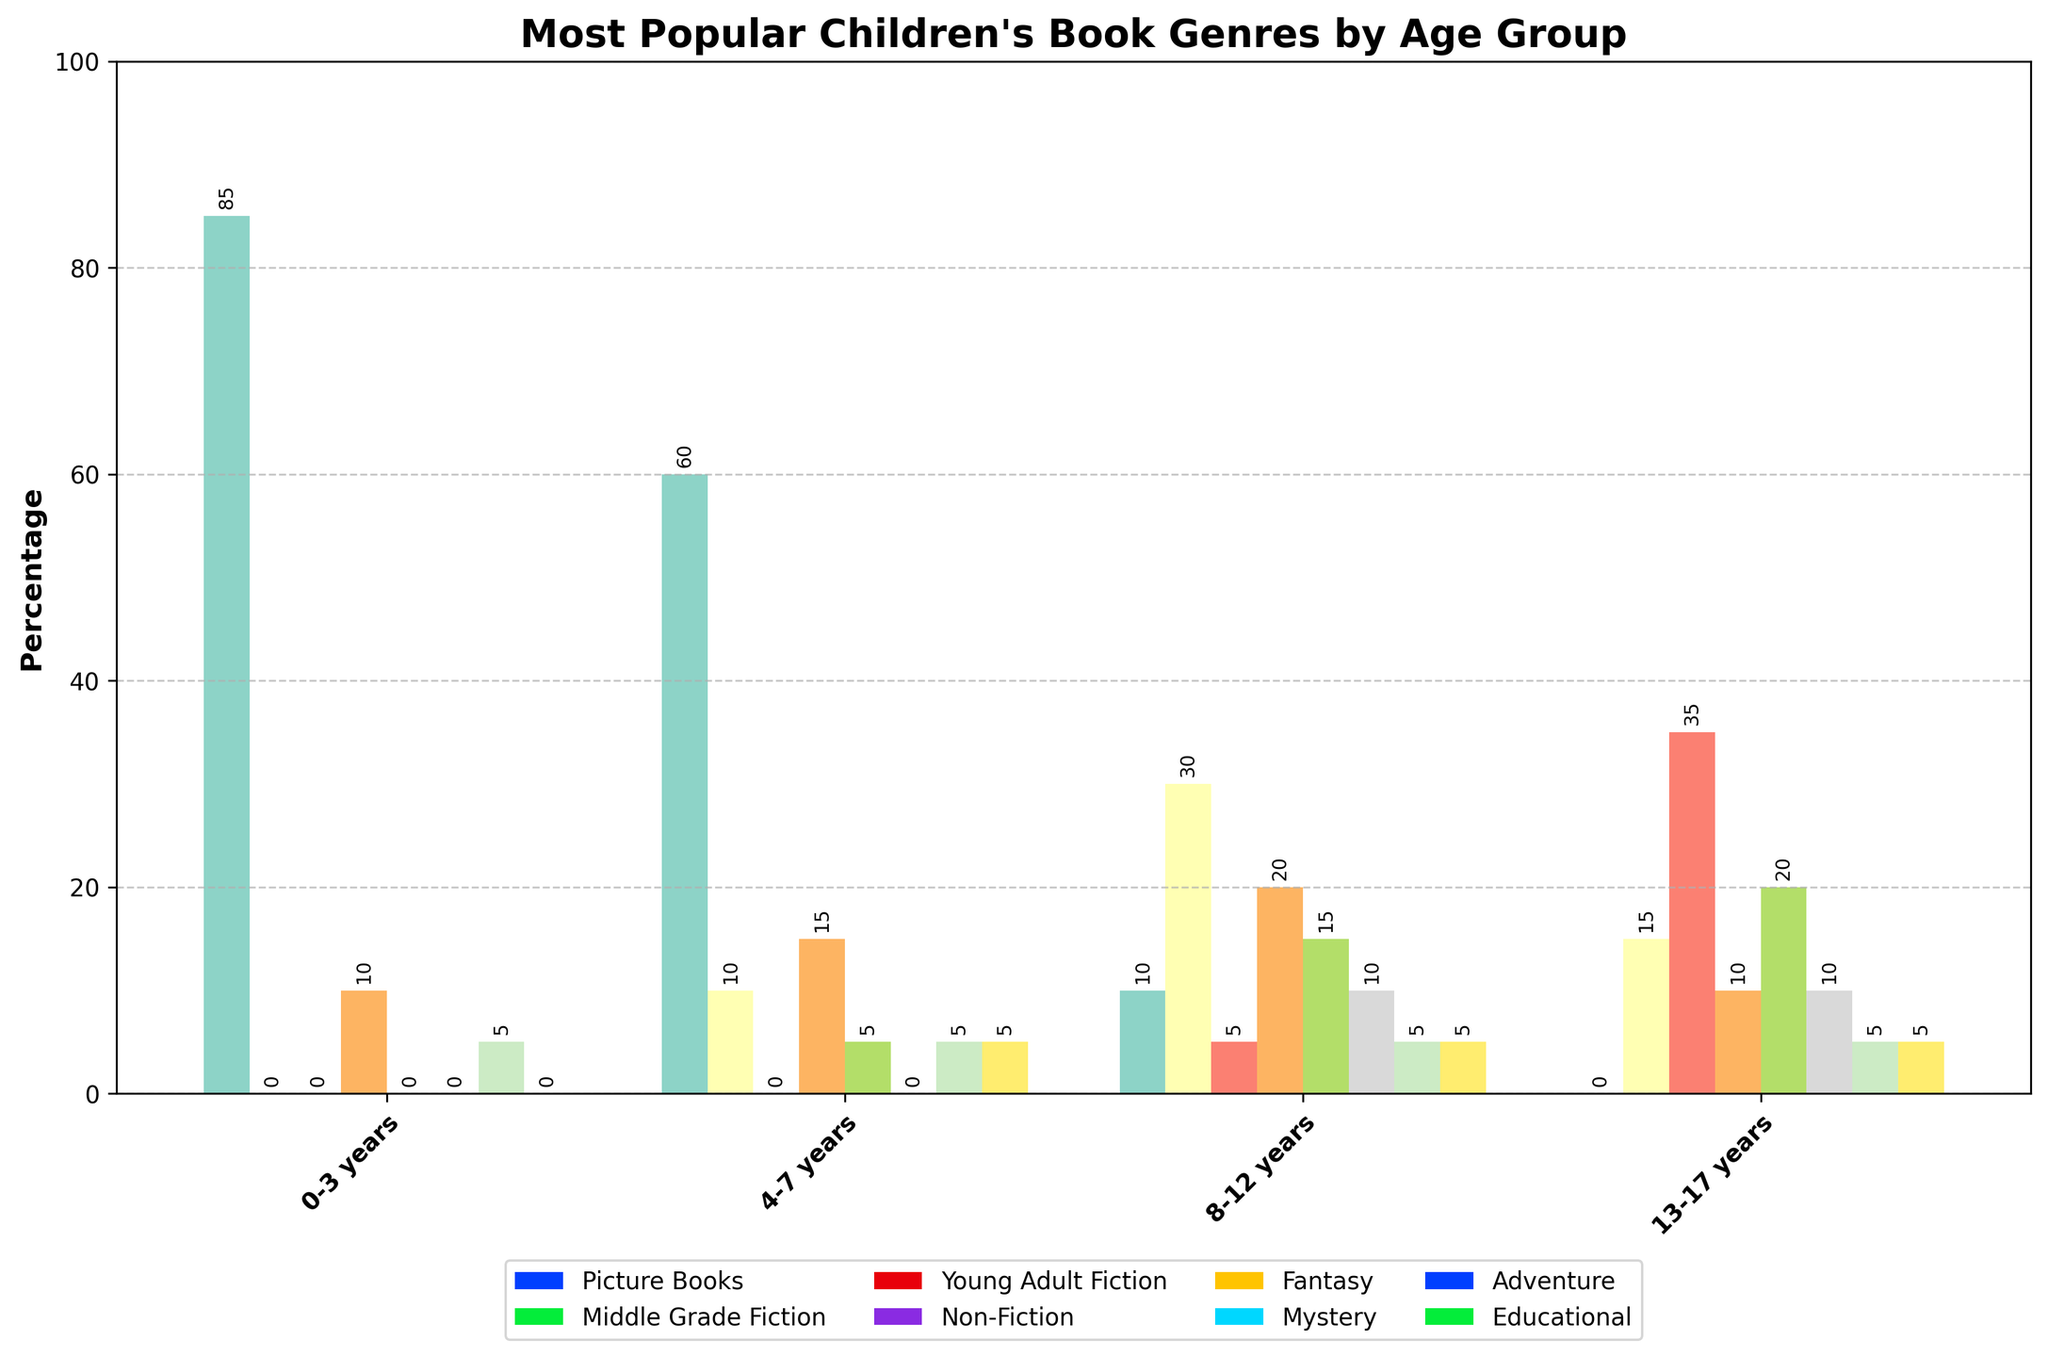What's the most popular genre for the 4-7 years age group? The highest bar in the 4-7 years category represents Picture Books, which reaches 60%.
Answer: Picture Books How many genres have a popularity of 10% or more in the 13-17 years age group? In the 13-17 years age group, the genres: Young Adult Fiction (35%), Fantasy (20%), and Non-Fiction (10%) reach or surpass 10%. Counting these, there are 3 genres.
Answer: 3 Which age group has the highest percentage for Middle Grade Fiction? Comparing the heights of the Middle Grade Fiction bars across all age groups, the 8-12 years group has the highest bar at 30%.
Answer: 8-12 years What is the combined percentage of genres accounting for at least 10% in the 0-3 years age group? In the 0-3 years age group, Picture Books (85%) and Non-Fiction (10%) exceed 10%. Adding these values: 85% + 10% = 95%.
Answer: 95% Compare the popularity of Fantasy and Mystery for the 8-12 years age group. Which one is more popular? For the 8-12 years age group, Fantasy has a percentage of 15% while Mystery has a percentage of 10%. Fantasy is the more popular genre.
Answer: Fantasy What is the difference in percentage between Adventure books for the 4-7 years and the 8-12 years age groups? The Adventure genre is 5% for both age groups 4-7 years and 8-12 years, so the difference is 5% - 5% = 0%.
Answer: 0% Which genre shows up for all age groups? By inspecting all the age groups, Non-Fiction appears in all of them with percentages of 10%, 15%, 20%, and 10% respectively.
Answer: Non-Fiction Which genre is the least popular for the 0-3 years age group? Several genres are tied for least popularity in the 0-3 years age group at 0%. These genres are Middle Grade Fiction, Young Adult Fiction, Fantasy, Mystery, Adventure, and Educational.
Answer: Multiple genres (Middle Grade Fiction, Young Adult Fiction, Fantasy, Mystery, Adventure, Educational) What is the average popularity of Young Adult Fiction across all age groups? First, convert Young Adult Fiction percentages: 0%, 0%, 5%, and 35%. Then sum them: 0 + 0 + 5 + 35 = 40. The average is 40 / 4 = 10%.
Answer: 10% Which age group shows the widest range in genre popularity? The range is measured by the difference between the highest and lowest percentage values in each group. For 0-3: 85% - 0% = 85%. For 4-7: 60% - 0% = 60%. For 8-12: 30% - 5% = 25%. For 13-17: 35% - 0% = 35%. The 0-3 years group has the widest range at 85%.
Answer: 0-3 years 